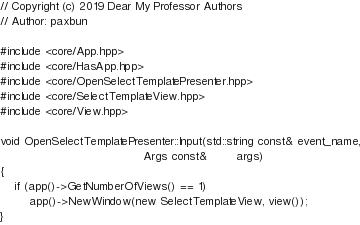Convert code to text. <code><loc_0><loc_0><loc_500><loc_500><_C++_>// Copyright (c) 2019 Dear My Professor Authors
// Author: paxbun

#include <core/App.hpp>
#include <core/HasApp.hpp>
#include <core/OpenSelectTemplatePresenter.hpp>
#include <core/SelectTemplateView.hpp>
#include <core/View.hpp>

void OpenSelectTemplatePresenter::Input(std::string const& event_name,
                                        Args const&        args)
{
    if (app()->GetNumberOfViews() == 1)
        app()->NewWindow(new SelectTemplateView, view());
}</code> 